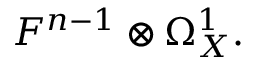Convert formula to latex. <formula><loc_0><loc_0><loc_500><loc_500>F ^ { n - 1 } \otimes \Omega _ { X } ^ { 1 } .</formula> 